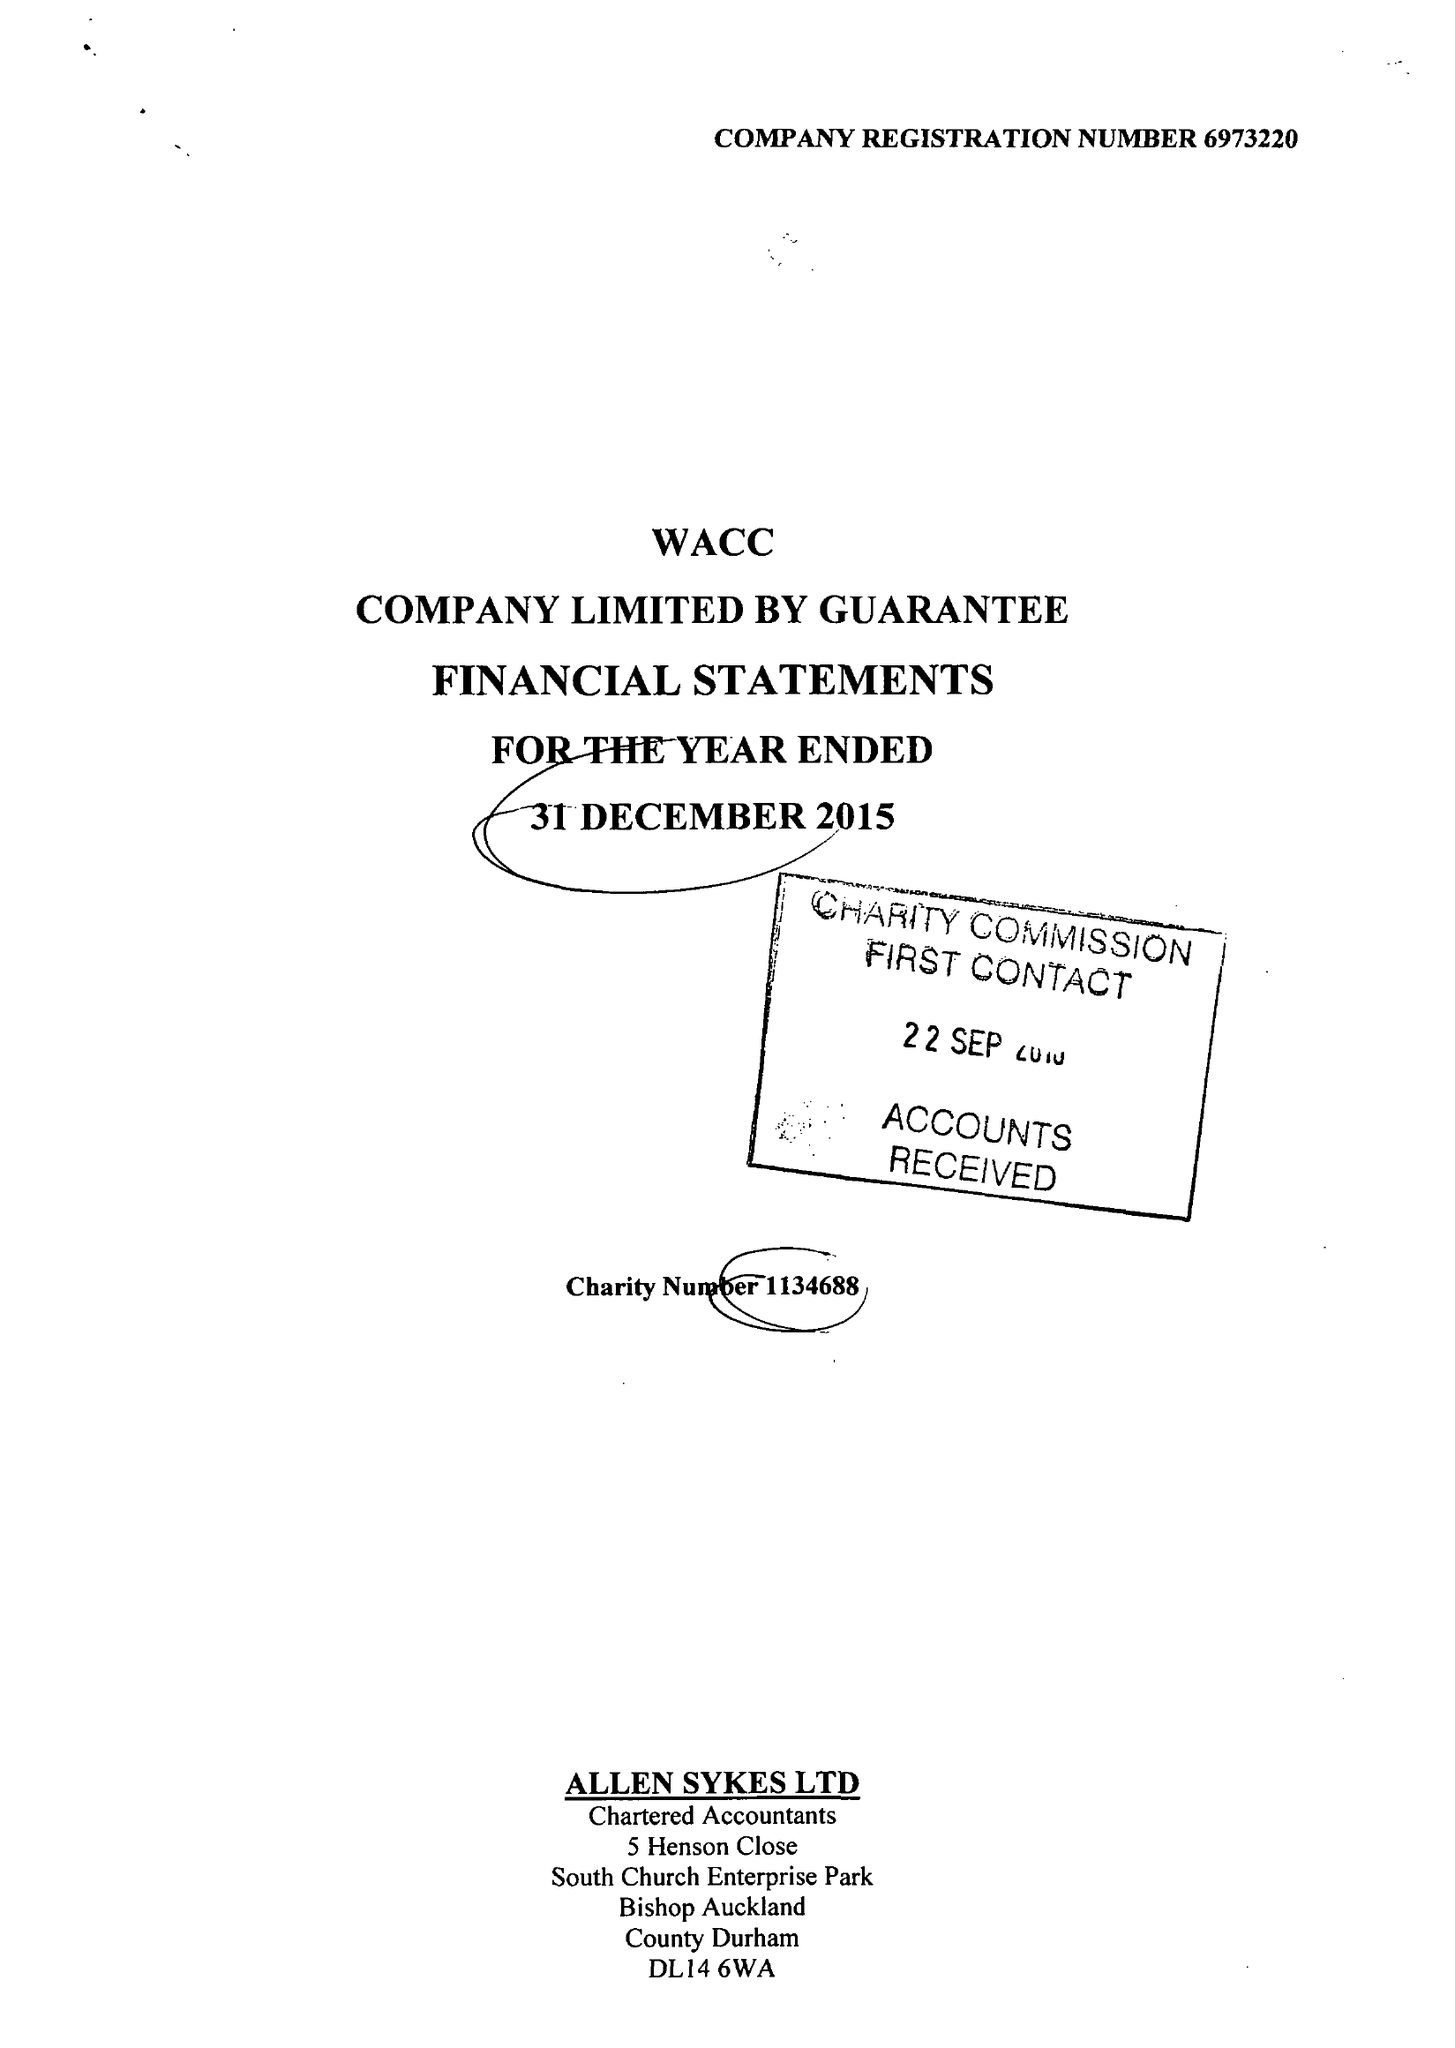What is the value for the spending_annually_in_british_pounds?
Answer the question using a single word or phrase. 63820.00 